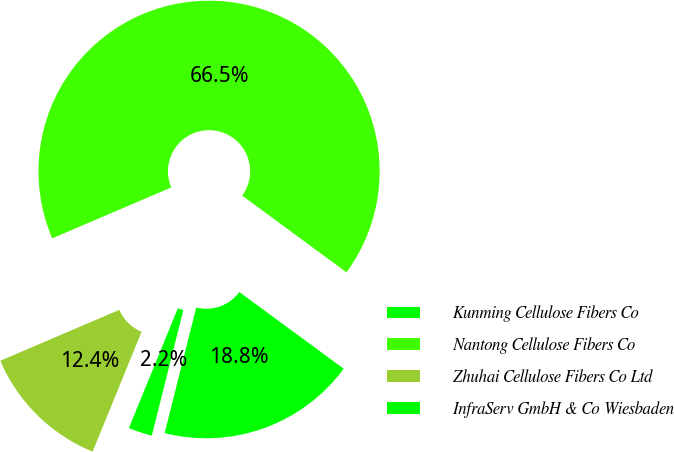<chart> <loc_0><loc_0><loc_500><loc_500><pie_chart><fcel>Kunming Cellulose Fibers Co<fcel>Nantong Cellulose Fibers Co<fcel>Zhuhai Cellulose Fibers Co Ltd<fcel>InfraServ GmbH & Co Wiesbaden<nl><fcel>18.83%<fcel>66.52%<fcel>12.4%<fcel>2.25%<nl></chart> 